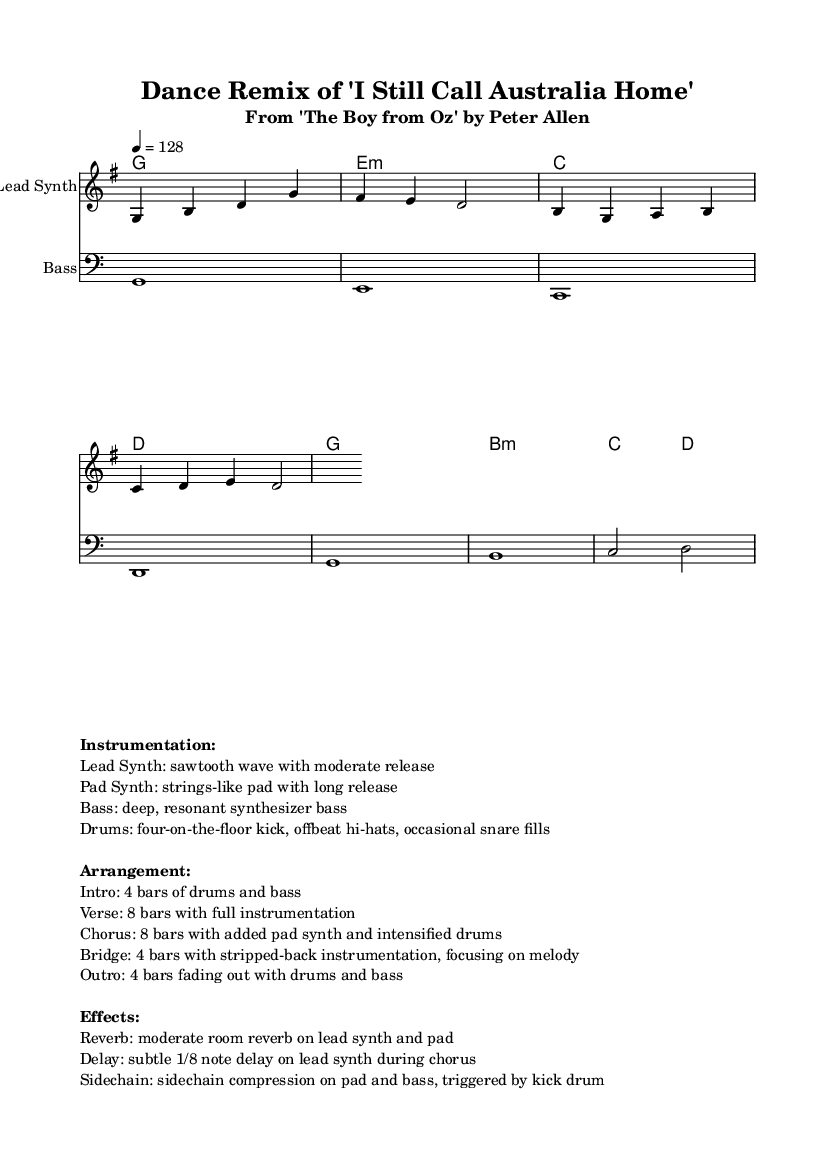What is the key signature of this music? The key signature is G major, which has one sharp (F#). This can be identified from the key signature symbol at the beginning of the staff, indicating the sharps in the scale.
Answer: G major What is the time signature of this music? The time signature is 4/4, which is indicated at the beginning of the piece. This means there are four beats per measure, and the quarter note gets the beat.
Answer: 4/4 What is the tempo marking for this piece? The tempo marking is 128 beats per minute, indicated at the beginning where it states "4 = 128". This means the quarter note (4) is played at 128 beats per minute.
Answer: 128 How many bars are in the introduction? The introduction consists of 4 bars as specified in the arrangement section provided in the markup. It states that the introduction includes the drums and bass for four measures.
Answer: 4 bars Which instrument plays the melody in this arrangement? The melody is performed by the Lead Synth, as indicated by the staff title in the score. It is specifically mentioned as "Lead Synth" in the notation.
Answer: Lead Synth What musical effect is applied to the lead synth during the chorus? The effect applied to the lead synth during the chorus is a subtle 1/8 note delay. This is mentioned in the effects section of the markup, indicating how the lead synth is treated in that specific section.
Answer: Delay What type of bass synthesizer is used in this piece? The piece uses a deep, resonant synthesizer bass as described under the instrumentation in the markup. This description gives insight into the nature of the bass sound.
Answer: Deep, resonant synthesizer bass 